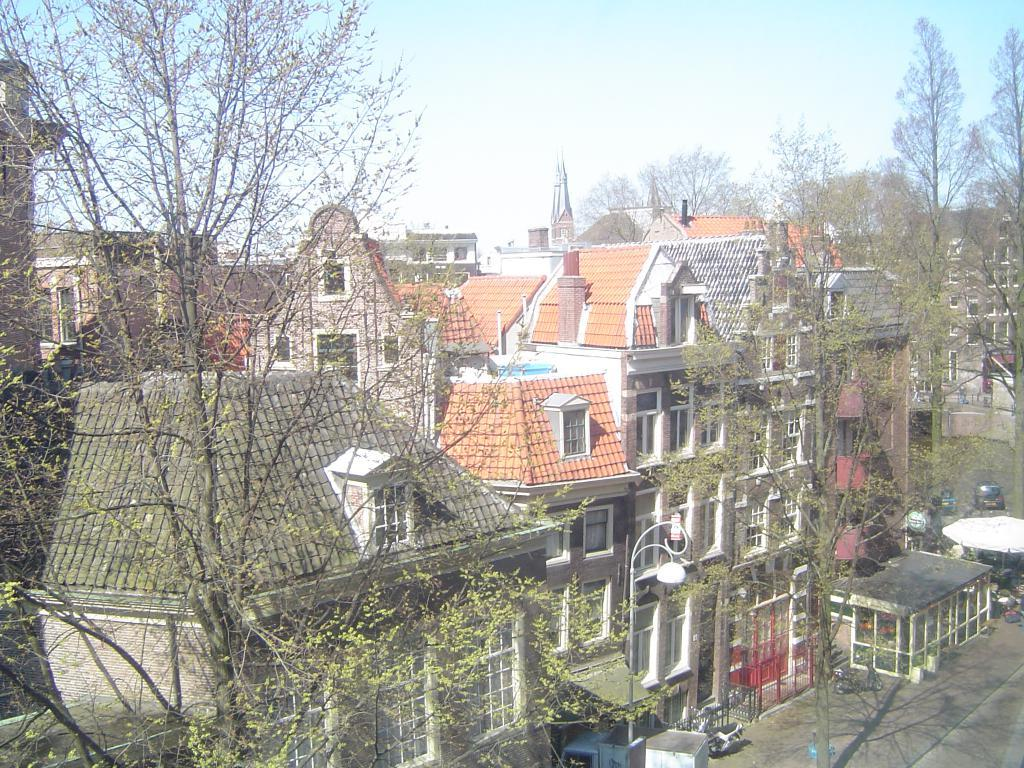What type of structures are visible in the image? There are buildings with roofs and windows in the image. What other natural elements can be seen in the image? There are trees in the image. What type of pathway is present in the image? There is a road in the image. What is located on the ground in the image? There is a pole on the ground in the image. What can be seen in the sky in the background of the image? There are clouds in the blue sky in the background of the image. What type of knife can be seen cutting through the glass in the image? There is no knife or glass present in the image. 